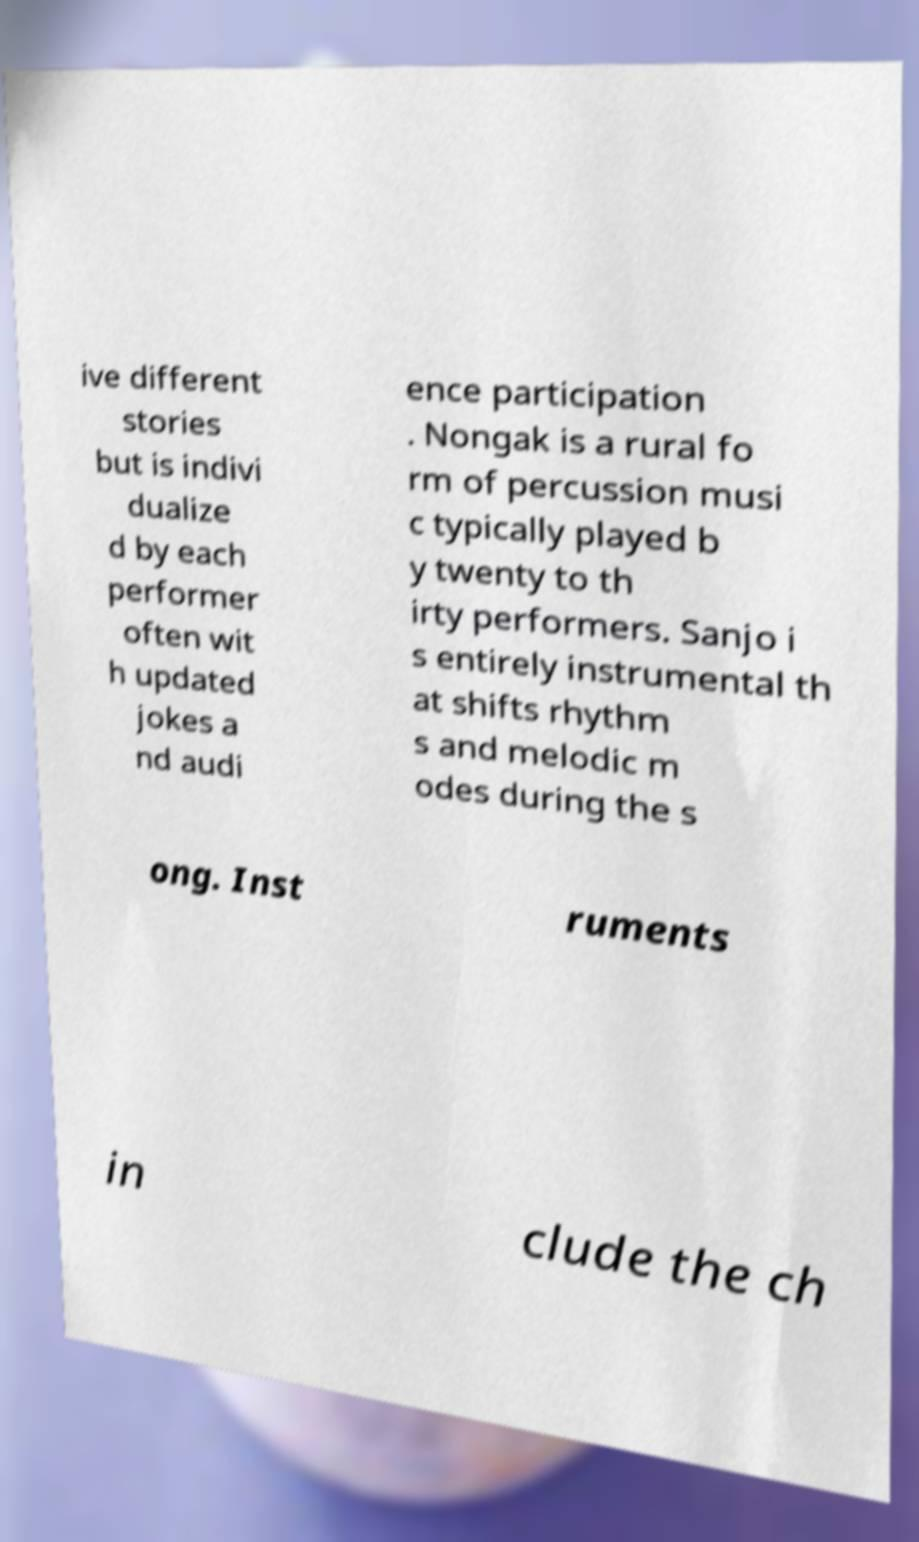There's text embedded in this image that I need extracted. Can you transcribe it verbatim? ive different stories but is indivi dualize d by each performer often wit h updated jokes a nd audi ence participation . Nongak is a rural fo rm of percussion musi c typically played b y twenty to th irty performers. Sanjo i s entirely instrumental th at shifts rhythm s and melodic m odes during the s ong. Inst ruments in clude the ch 